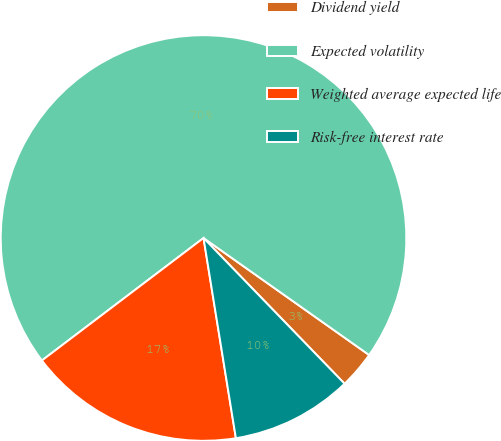Convert chart to OTSL. <chart><loc_0><loc_0><loc_500><loc_500><pie_chart><fcel>Dividend yield<fcel>Expected volatility<fcel>Weighted average expected life<fcel>Risk-free interest rate<nl><fcel>2.97%<fcel>70.11%<fcel>17.23%<fcel>9.69%<nl></chart> 